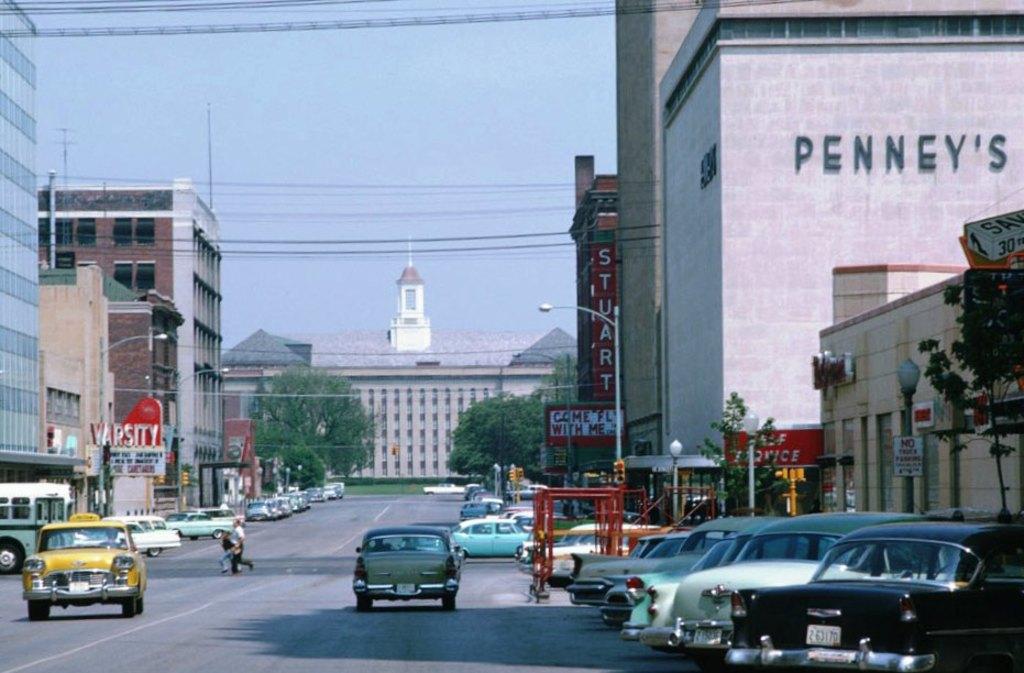What is the name of the store?
Offer a terse response. Penney's. What movie is showing at the stuart theatre?
Provide a short and direct response. Come fly with me. 